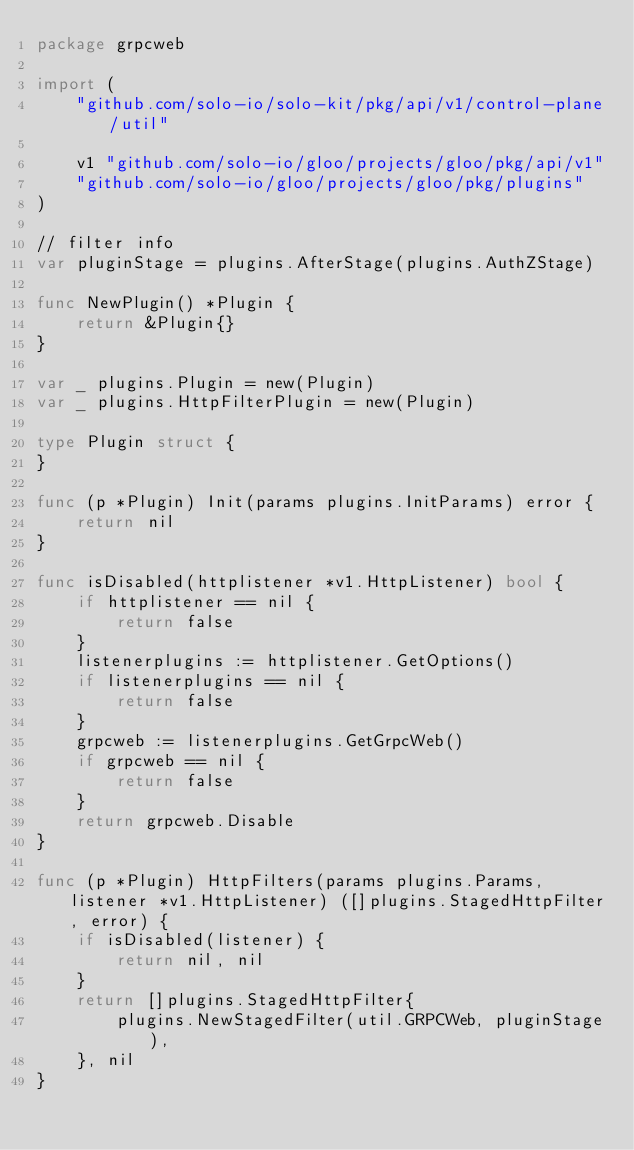<code> <loc_0><loc_0><loc_500><loc_500><_Go_>package grpcweb

import (
	"github.com/solo-io/solo-kit/pkg/api/v1/control-plane/util"

	v1 "github.com/solo-io/gloo/projects/gloo/pkg/api/v1"
	"github.com/solo-io/gloo/projects/gloo/pkg/plugins"
)

// filter info
var pluginStage = plugins.AfterStage(plugins.AuthZStage)

func NewPlugin() *Plugin {
	return &Plugin{}
}

var _ plugins.Plugin = new(Plugin)
var _ plugins.HttpFilterPlugin = new(Plugin)

type Plugin struct {
}

func (p *Plugin) Init(params plugins.InitParams) error {
	return nil
}

func isDisabled(httplistener *v1.HttpListener) bool {
	if httplistener == nil {
		return false
	}
	listenerplugins := httplistener.GetOptions()
	if listenerplugins == nil {
		return false
	}
	grpcweb := listenerplugins.GetGrpcWeb()
	if grpcweb == nil {
		return false
	}
	return grpcweb.Disable
}

func (p *Plugin) HttpFilters(params plugins.Params, listener *v1.HttpListener) ([]plugins.StagedHttpFilter, error) {
	if isDisabled(listener) {
		return nil, nil
	}
	return []plugins.StagedHttpFilter{
		plugins.NewStagedFilter(util.GRPCWeb, pluginStage),
	}, nil
}
</code> 